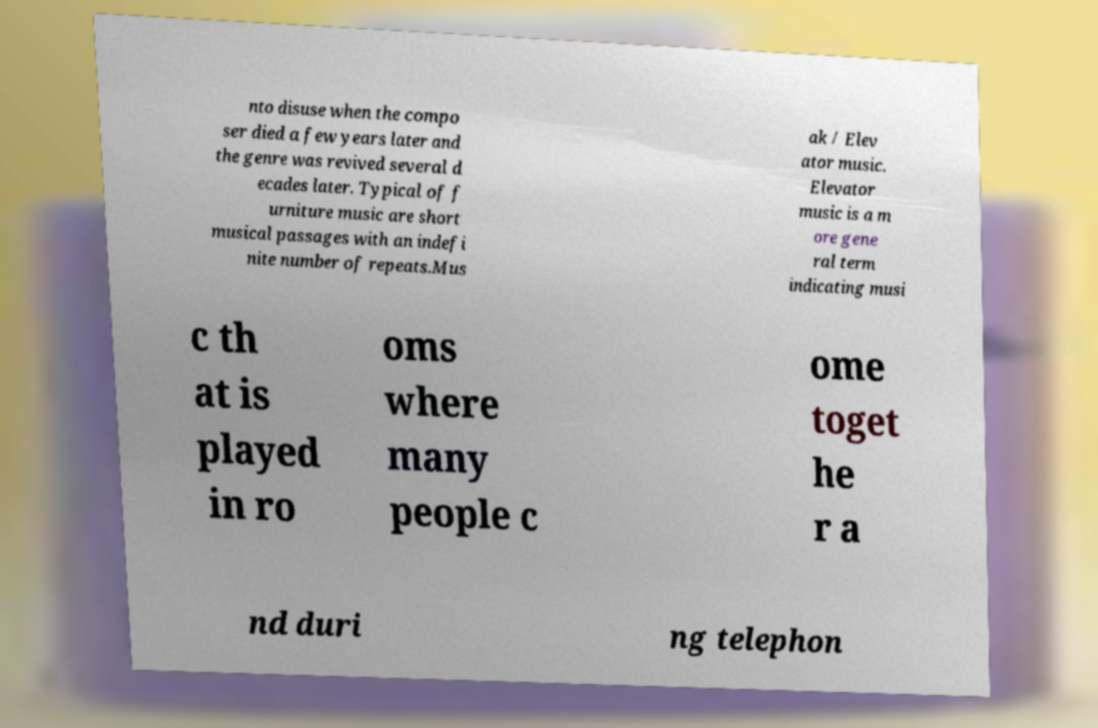Can you accurately transcribe the text from the provided image for me? nto disuse when the compo ser died a few years later and the genre was revived several d ecades later. Typical of f urniture music are short musical passages with an indefi nite number of repeats.Mus ak / Elev ator music. Elevator music is a m ore gene ral term indicating musi c th at is played in ro oms where many people c ome toget he r a nd duri ng telephon 